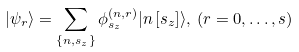<formula> <loc_0><loc_0><loc_500><loc_500>| \psi _ { r } \rangle = \sum _ { \{ n , s _ { z } \} } \phi _ { s _ { z } } ^ { ( n , r ) } | n \left [ s _ { z } \right ] \rangle , \, ( r = 0 , \dots , s )</formula> 